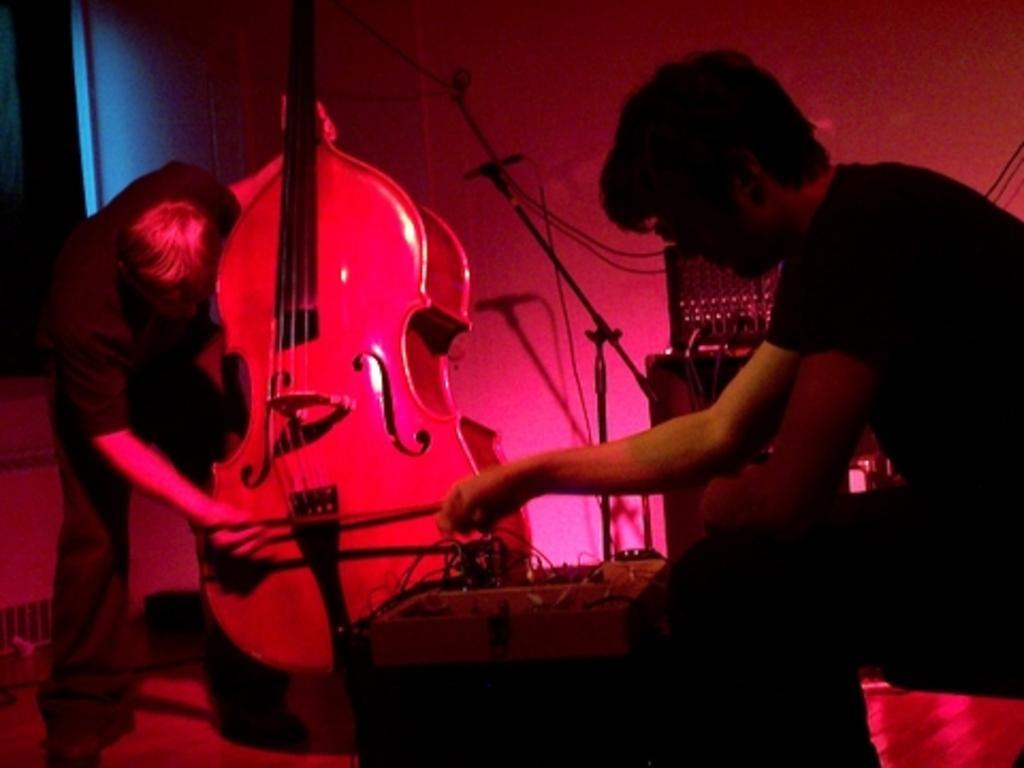How would you summarize this image in a sentence or two? Here on the right we can see a person sitting and adjusting a musical instrument and on the left we can see a person playing a violin and there is a microphone present in the middle and there are other musical instruments present 